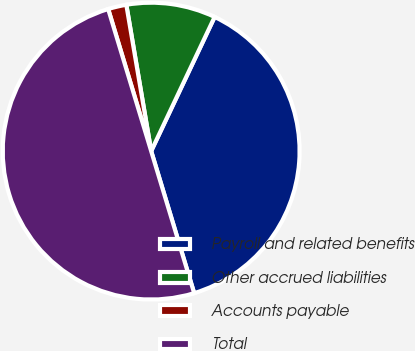Convert chart to OTSL. <chart><loc_0><loc_0><loc_500><loc_500><pie_chart><fcel>Payroll and related benefits<fcel>Other accrued liabilities<fcel>Accounts payable<fcel>Total<nl><fcel>38.29%<fcel>9.71%<fcel>2.0%<fcel>50.0%<nl></chart> 